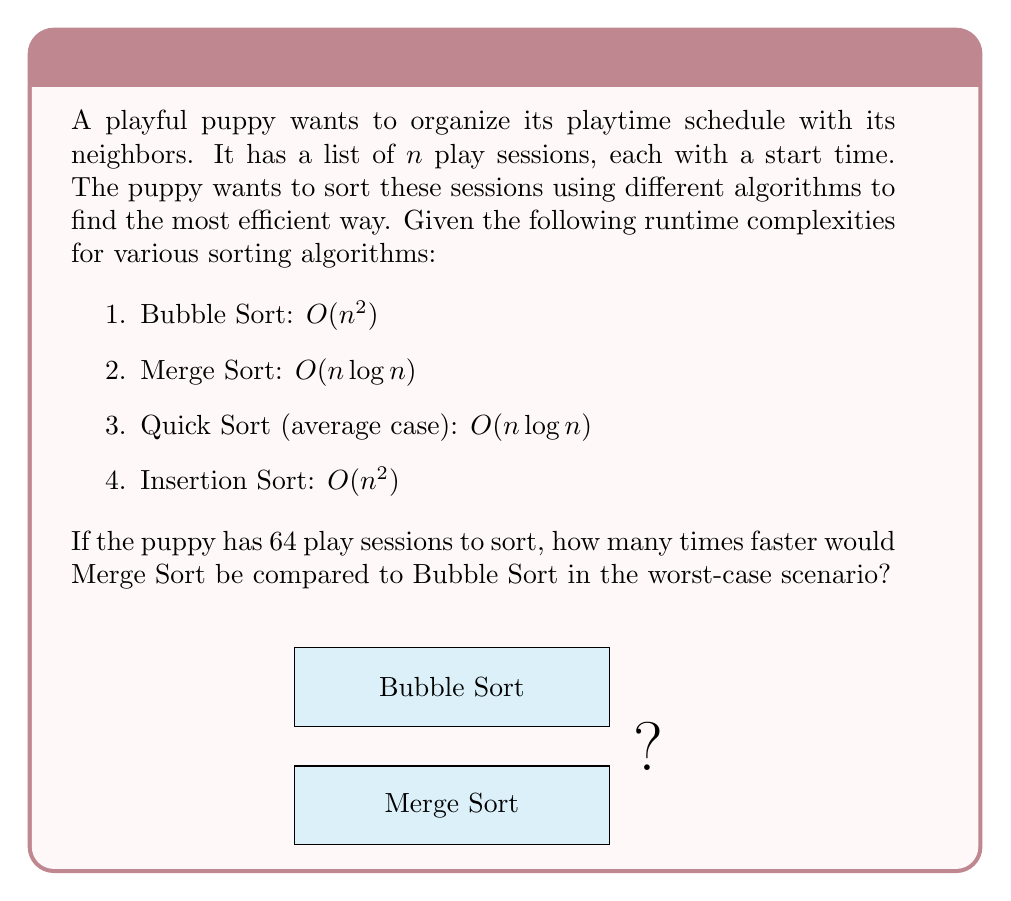Can you answer this question? Let's approach this step-by-step:

1) First, we need to calculate the runtime for both algorithms with $n = 64$:

   Bubble Sort (worst-case): $O(n^2) = O(64^2) = O(4096)$
   Merge Sort (worst-case): $O(n \log n) = O(64 \log 64) = O(64 * 6) = O(384)$

2) To find how many times faster Merge Sort is, we need to divide the Bubble Sort runtime by the Merge Sort runtime:

   $\frac{O(n^2)}{O(n \log n)} = \frac{O(4096)}{O(384)} = \frac{4096}{384} = 10.67$

3) However, we need to be careful here. Big O notation gives us the upper bound, not the exact number of operations. The actual number of operations will be some constant multiple of these values.

4) Despite this, the ratio between these two will give us a good approximation of the speed difference, especially for large n.

5) Therefore, we can conclude that for $n = 64$, Merge Sort would be approximately 10.67 times faster than Bubble Sort in the worst-case scenario.

6) Rounding to the nearest whole number, we get 11.
Answer: 11 times faster 